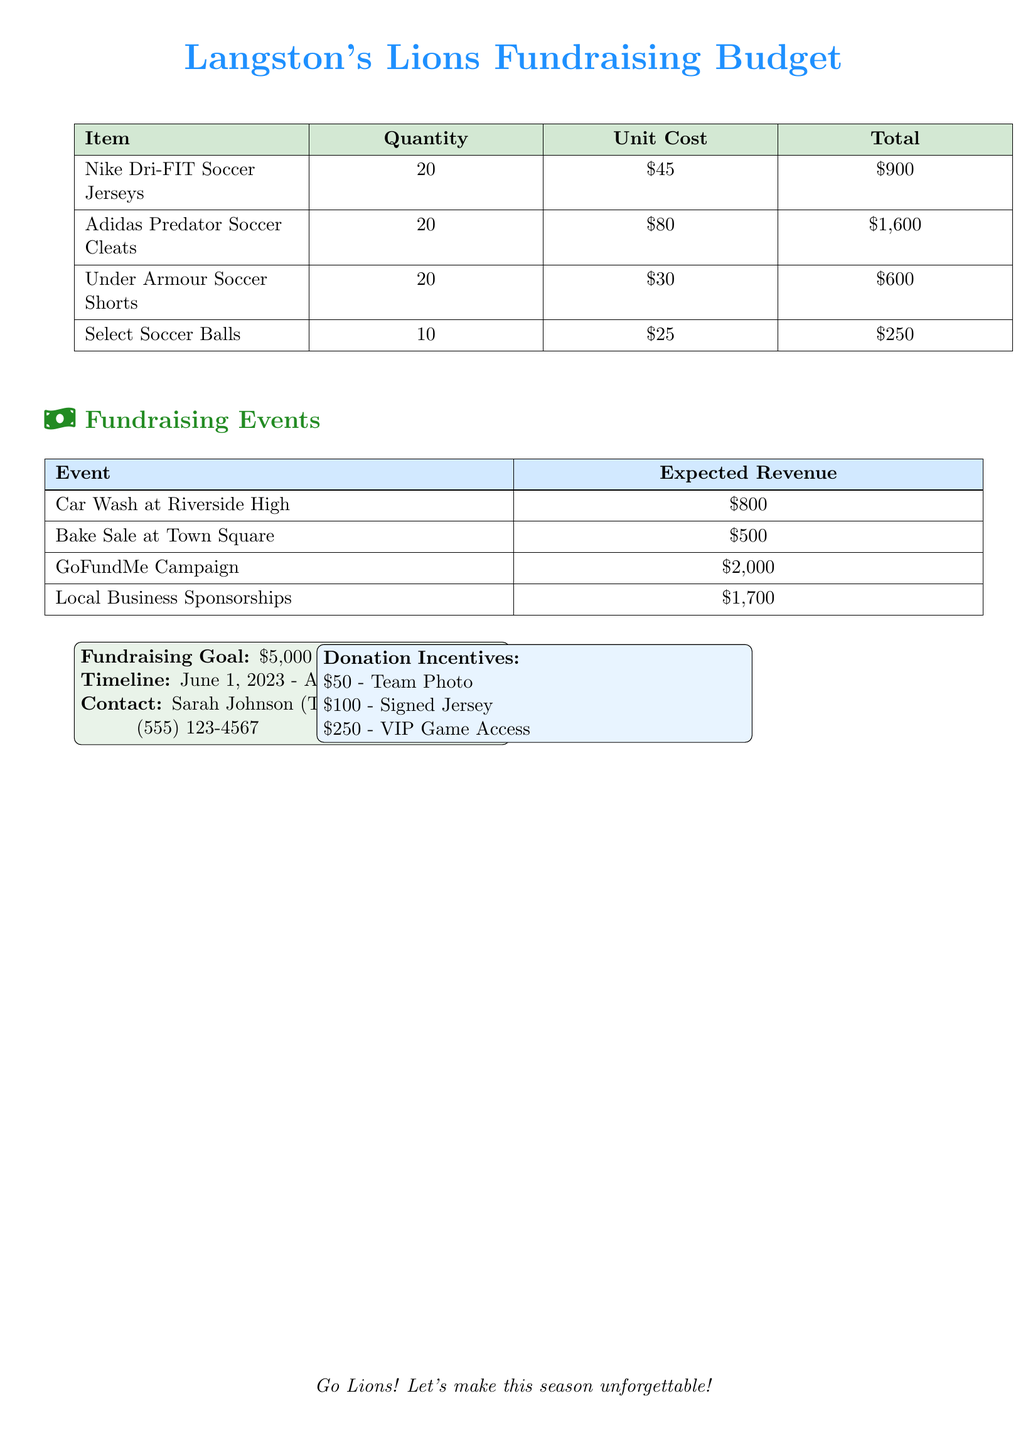What is the fundraising goal? The document specifies the fundraising goal as $5,000.
Answer: $5,000 How many Adidas Predator Soccer Cleats are needed? The budget lists the quantity of Adidas Predator Soccer Cleats as 20.
Answer: 20 What is the expected revenue from the GoFundMe Campaign? The expected revenue from the GoFundMe Campaign is stated as $2,000.
Answer: $2,000 Who is the contact person for the fundraising plan? The document names Sarah Johnson as the contact for the fundraising plan.
Answer: Sarah Johnson What is the timeline for the fundraising activities? The timeline is defined as June 1, 2023 - August 15, 2023.
Answer: June 1, 2023 - August 15, 2023 How much will it cost to purchase 10 Select Soccer Balls? The document shows that the total cost for 10 Select Soccer Balls at $25 each is $250.
Answer: $250 What are the donation incentives for contributors? The document lists three donation incentives: $50 for a team photo, $100 for a signed jersey, and $250 for VIP game access.
Answer: Team Photo, Signed Jersey, VIP Game Access What is the total cost for the Nike Dri-FIT Soccer Jerseys? The total cost for 20 Nike Dri-FIT Soccer Jerseys at $45 each is $900.
Answer: $900 What is the expected revenue from the Bake Sale at Town Square? The expected revenue from the Bake Sale at Town Square is mentioned as $500.
Answer: $500 